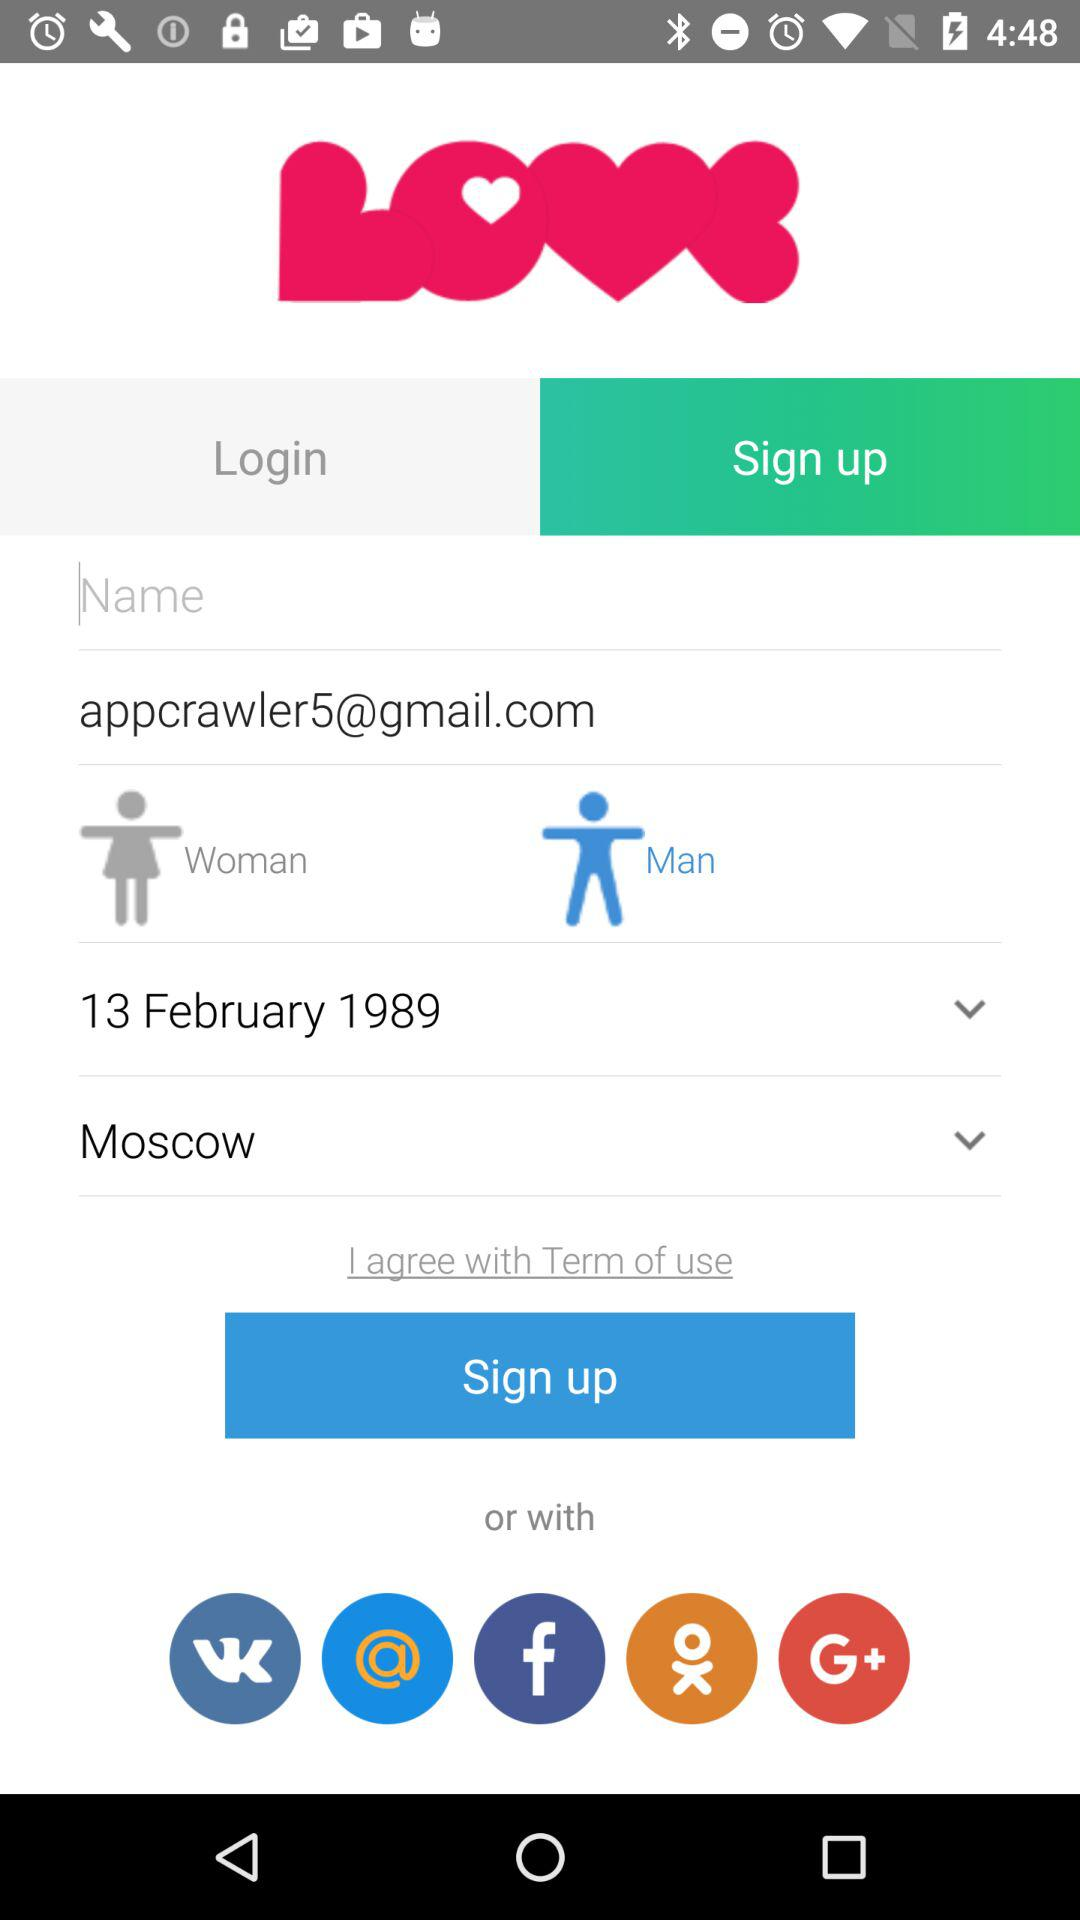What is the email address? The email address is appcrawler5@gmail.com. 